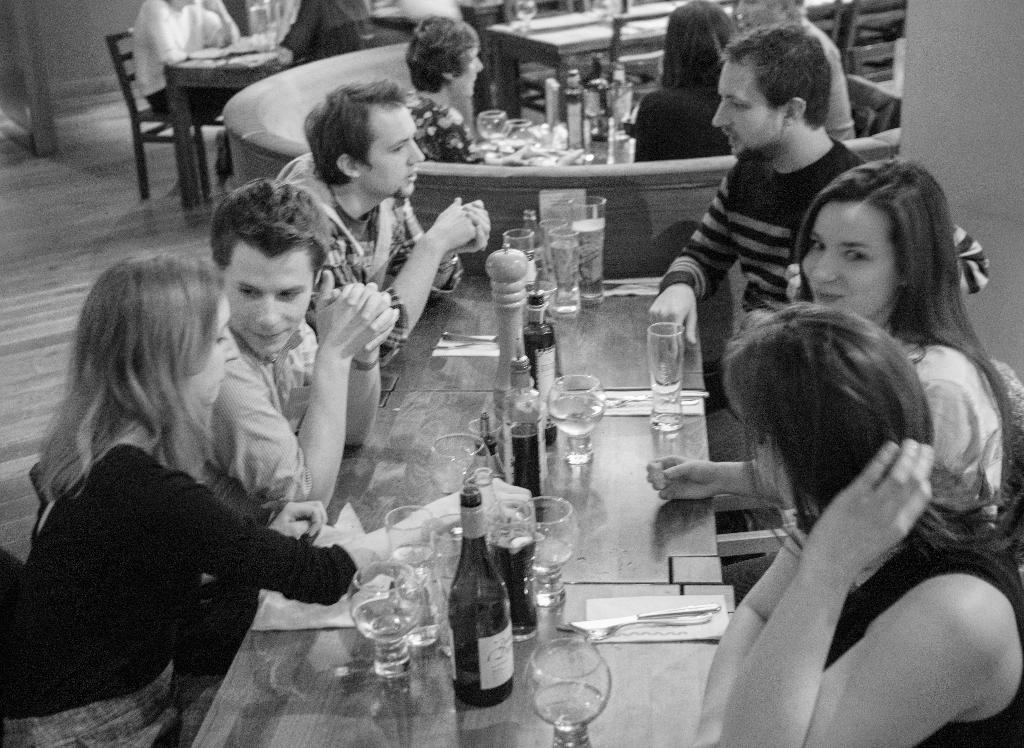Describe this image in one or two sentences. On the table glass,bottle,spoon and people are sitting around the table,here there is chair. 